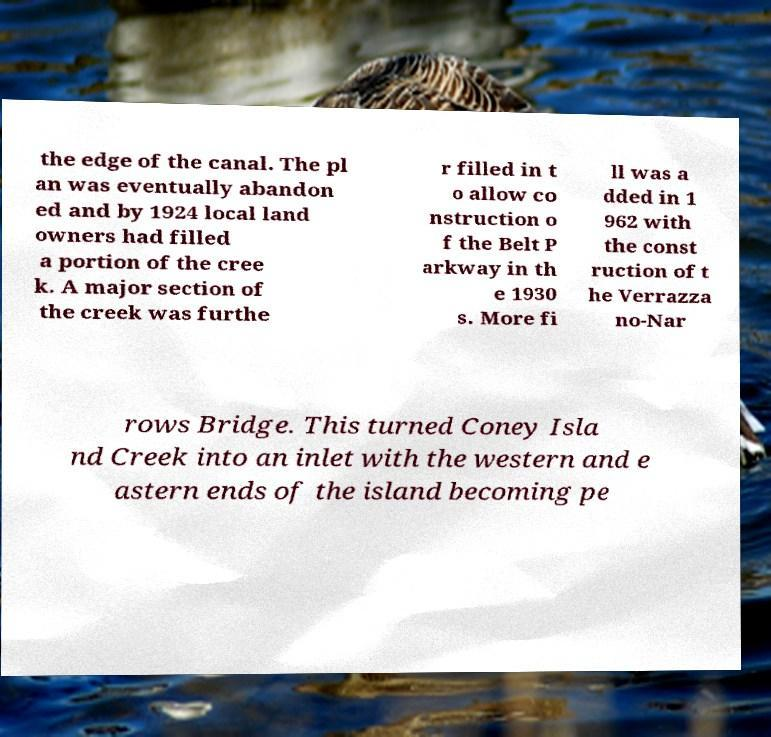What messages or text are displayed in this image? I need them in a readable, typed format. the edge of the canal. The pl an was eventually abandon ed and by 1924 local land owners had filled a portion of the cree k. A major section of the creek was furthe r filled in t o allow co nstruction o f the Belt P arkway in th e 1930 s. More fi ll was a dded in 1 962 with the const ruction of t he Verrazza no-Nar rows Bridge. This turned Coney Isla nd Creek into an inlet with the western and e astern ends of the island becoming pe 